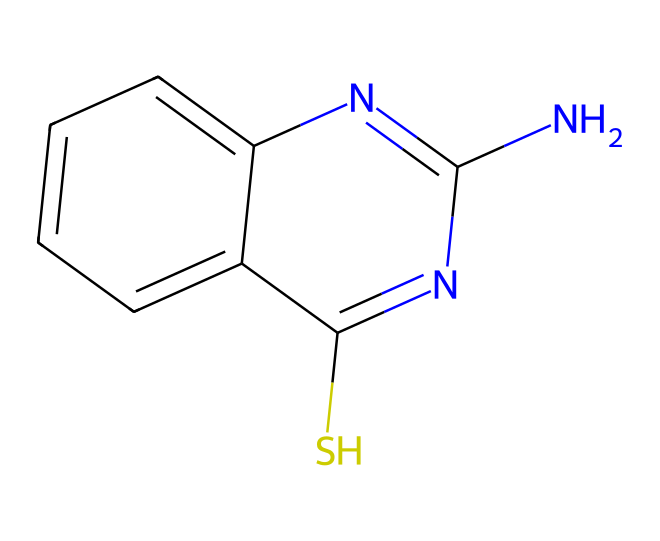What is the chemical name of this compound? The SMILES representation corresponds to a chemical known as thiabendazole, where its structure displays the arrangement of carbon, nitrogen, and sulfur atoms leading to this specific fungicide name.
Answer: thiabendazole How many nitrogen atoms are present in the structure? By analyzing the SMILES representation, we can identify two nitrogen atoms in the chemical structure, which are marked by the 'n' characters.
Answer: 2 How many sulfur atoms are part of this molecule? In the provided SMILES, there is one sulfur atom indicated by the 'S' character, showing that it is included in the molecular structure.
Answer: 1 What type of chemical is thiabendazole classified as? Thiabendazole is a fungicide. Its chemical structure includes features typical of fungicides, such as a benzothiazole system, contributing to its mode of action against fungi.
Answer: fungicide What functional groups are present in the molecule? The molecule contains both a benzimidazole and a thiazole functional group, which can be identified through the structure and the arrangement of the atoms in the SMILES notation.
Answer: benzimidazole, thiazole What is the molecular formula of thiabendazole? To ascertain the molecular formula, one counts the carbon, hydrogen, nitrogen, and sulfur atoms from the structure, leading to the formula C10H9N3S.
Answer: C10H9N3S How does the structure of thiabendazole contribute to its antifungal properties? The presence of the nitrogen atoms and the specific arrangement of the carbon and sulfur atoms enhance interactions with fungal enzymes, inhibiting growth. This is characteristic of many effective fungicides.
Answer: inhibits fungal growth 